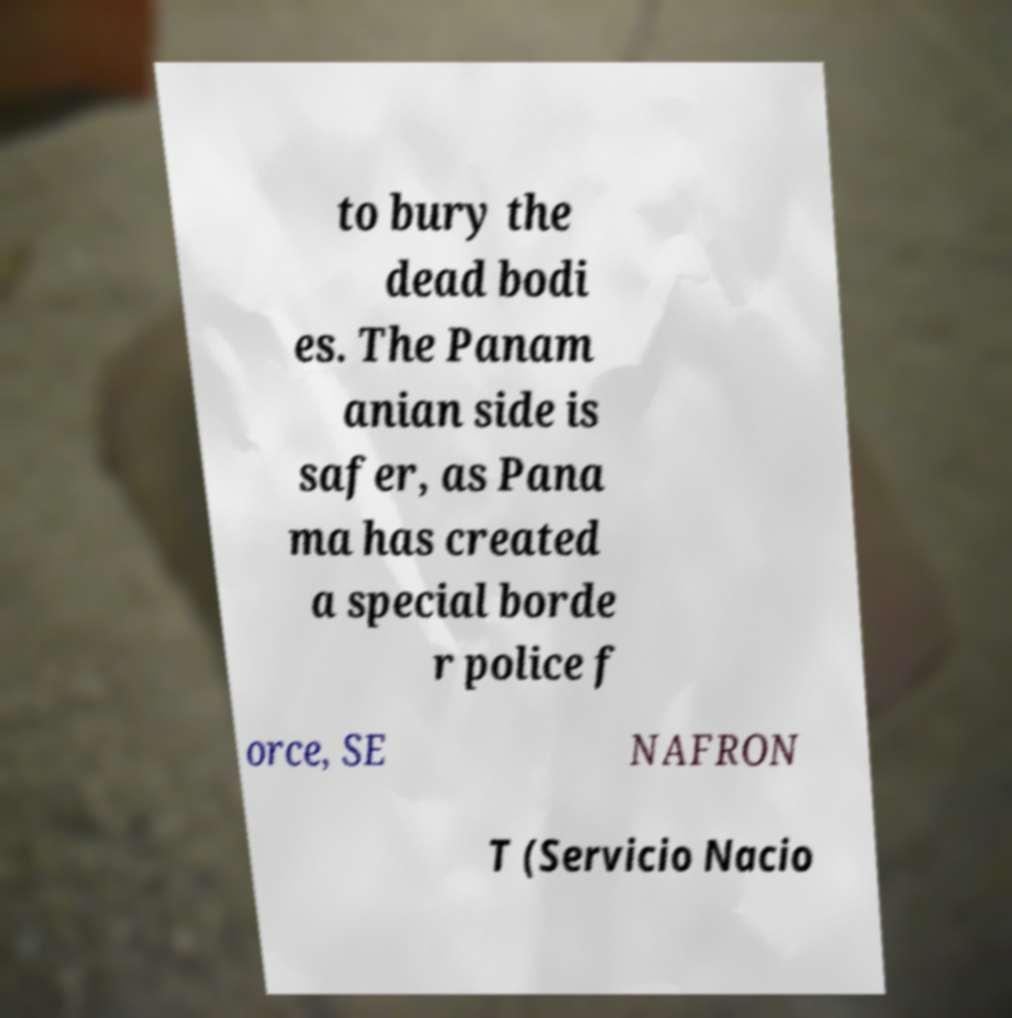For documentation purposes, I need the text within this image transcribed. Could you provide that? to bury the dead bodi es. The Panam anian side is safer, as Pana ma has created a special borde r police f orce, SE NAFRON T (Servicio Nacio 